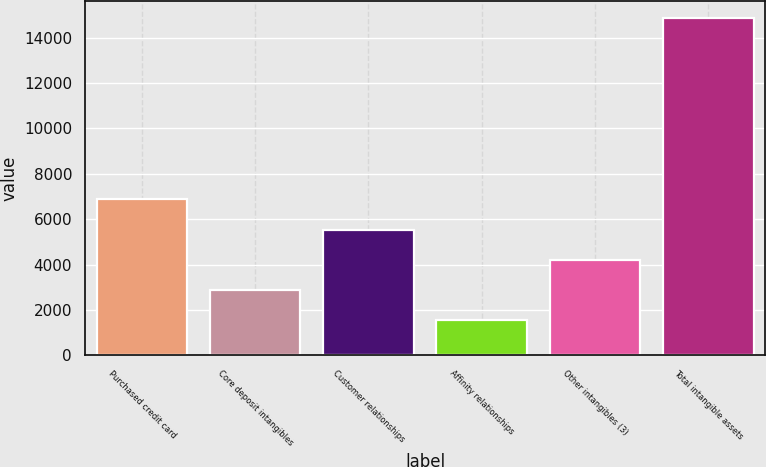<chart> <loc_0><loc_0><loc_500><loc_500><bar_chart><fcel>Purchased credit card<fcel>Core deposit intangibles<fcel>Customer relationships<fcel>Affinity relationships<fcel>Other intangibles (3)<fcel>Total intangible assets<nl><fcel>6875.6<fcel>2885.9<fcel>5545.7<fcel>1556<fcel>4215.8<fcel>14855<nl></chart> 